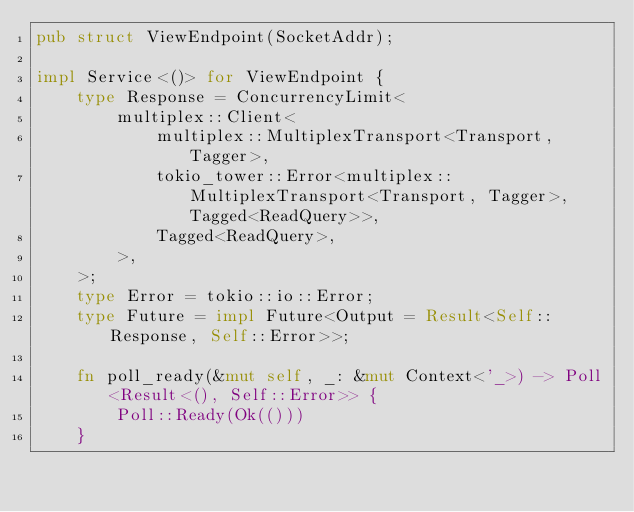<code> <loc_0><loc_0><loc_500><loc_500><_Rust_>pub struct ViewEndpoint(SocketAddr);

impl Service<()> for ViewEndpoint {
    type Response = ConcurrencyLimit<
        multiplex::Client<
            multiplex::MultiplexTransport<Transport, Tagger>,
            tokio_tower::Error<multiplex::MultiplexTransport<Transport, Tagger>, Tagged<ReadQuery>>,
            Tagged<ReadQuery>,
        >,
    >;
    type Error = tokio::io::Error;
    type Future = impl Future<Output = Result<Self::Response, Self::Error>>;

    fn poll_ready(&mut self, _: &mut Context<'_>) -> Poll<Result<(), Self::Error>> {
        Poll::Ready(Ok(()))
    }
</code> 